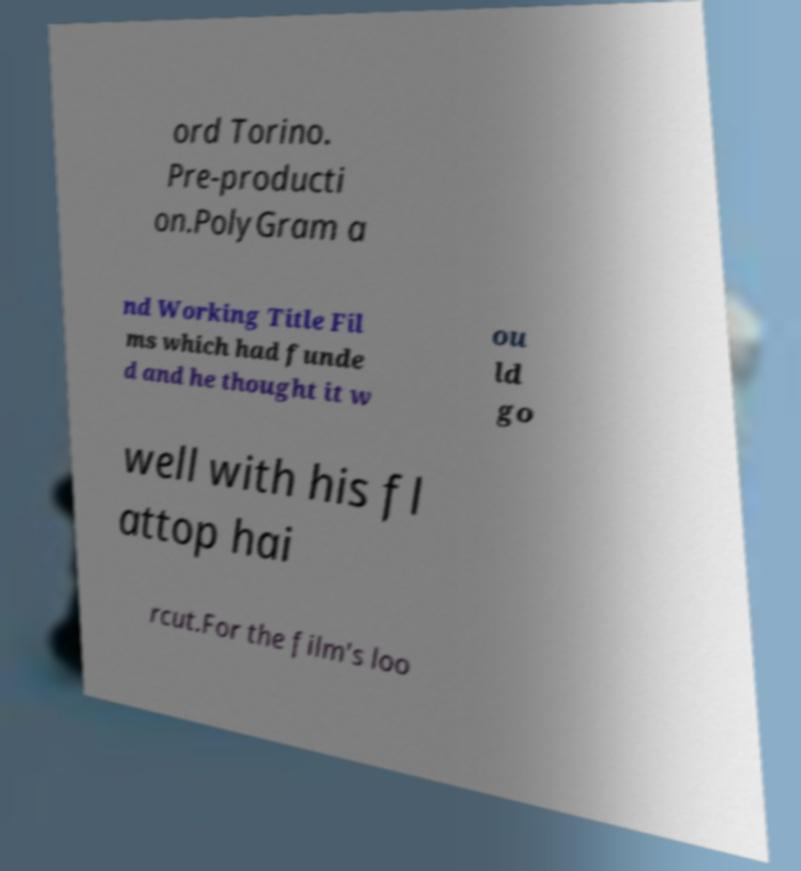Can you accurately transcribe the text from the provided image for me? ord Torino. Pre-producti on.PolyGram a nd Working Title Fil ms which had funde d and he thought it w ou ld go well with his fl attop hai rcut.For the film's loo 